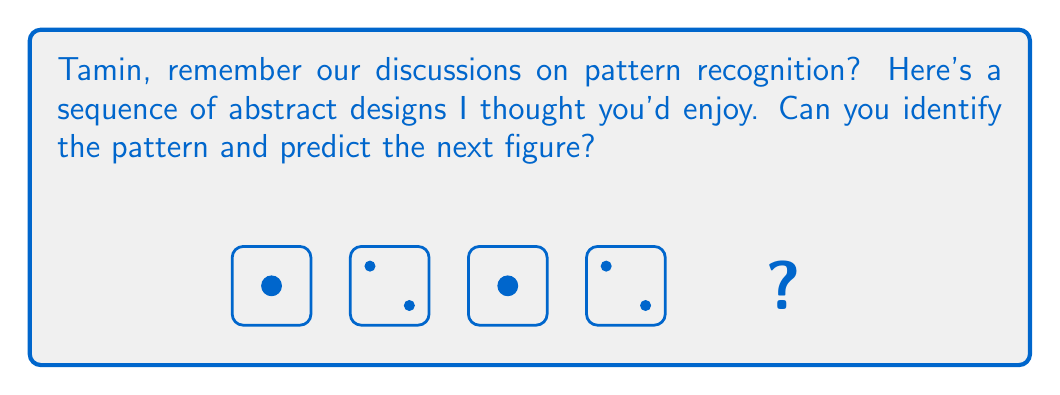What is the answer to this math problem? Let's analyze this pattern step-by-step, Tamin:

1) We see a sequence of four squares, each containing circles.

2) The squares remain constant in size throughout the sequence.

3) The circle pattern alternates:
   - In odd-numbered squares (1st, 3rd), there's one large circle in the center.
   - In even-numbered squares (2nd, 4th), there are two smaller circles in opposite corners.

4) The size relationship between the large and small circles:
   - The radius of the large circle is twice that of the small circles.

5) The position of the small circles:
   - They are always in the top-left and bottom-right corners of the even-numbered squares.

6) Since we're asked for the next figure, which would be the 5th in the sequence, we need to continue the pattern.

7) The 5th figure would follow the pattern of the 1st and 3rd figures, as it's an odd-numbered position in the sequence.

Therefore, the next figure should be a square with one large circle in the center, identical to the 1st and 3rd figures in the sequence.
Answer: A square with one large circle in the center 